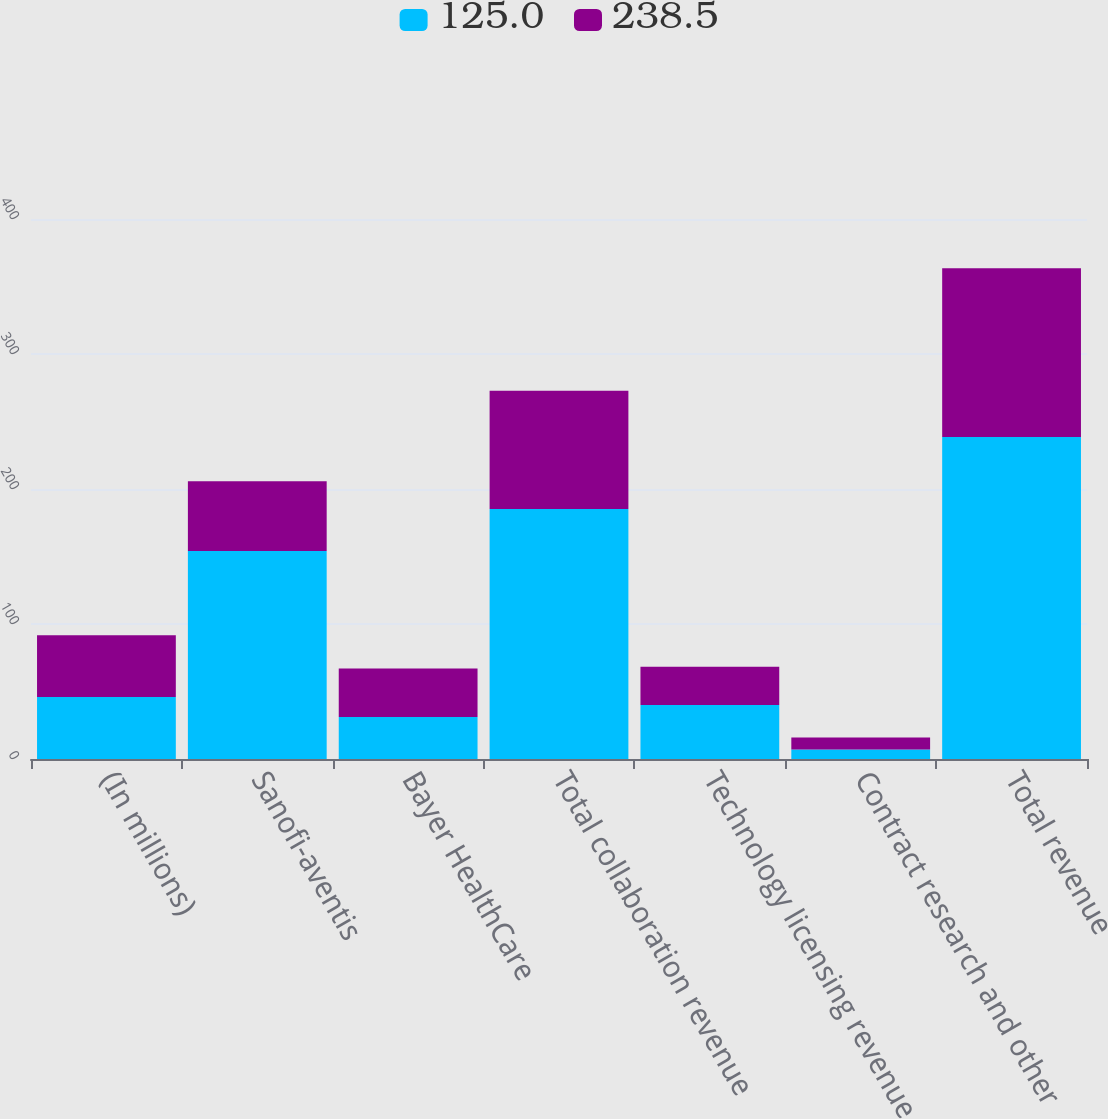<chart> <loc_0><loc_0><loc_500><loc_500><stacked_bar_chart><ecel><fcel>(In millions)<fcel>Sanofi-aventis<fcel>Bayer HealthCare<fcel>Total collaboration revenue<fcel>Technology licensing revenue<fcel>Contract research and other<fcel>Total revenue<nl><fcel>125<fcel>45.85<fcel>154<fcel>31.2<fcel>185.2<fcel>40<fcel>7<fcel>238.5<nl><fcel>238.5<fcel>45.85<fcel>51.7<fcel>35.9<fcel>87.6<fcel>28.4<fcel>9<fcel>125<nl></chart> 